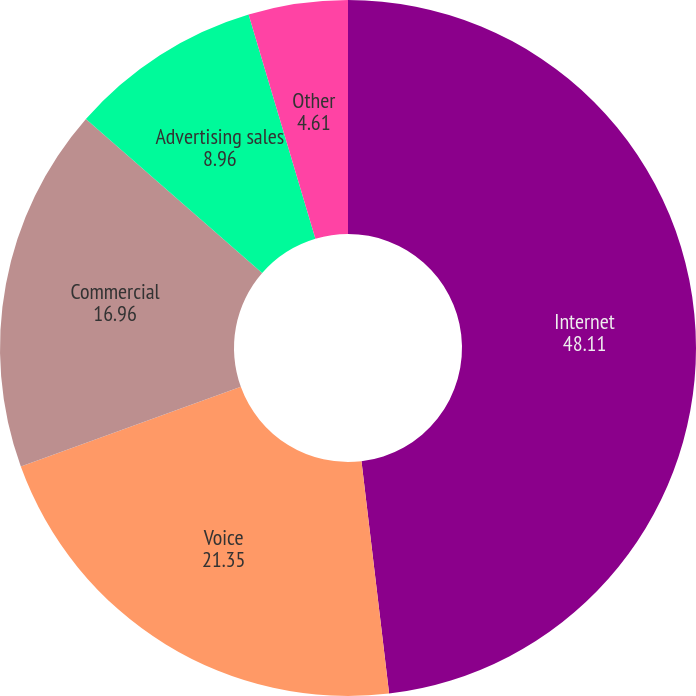Convert chart. <chart><loc_0><loc_0><loc_500><loc_500><pie_chart><fcel>Internet<fcel>Voice<fcel>Commercial<fcel>Advertising sales<fcel>Other<nl><fcel>48.11%<fcel>21.35%<fcel>16.96%<fcel>8.96%<fcel>4.61%<nl></chart> 